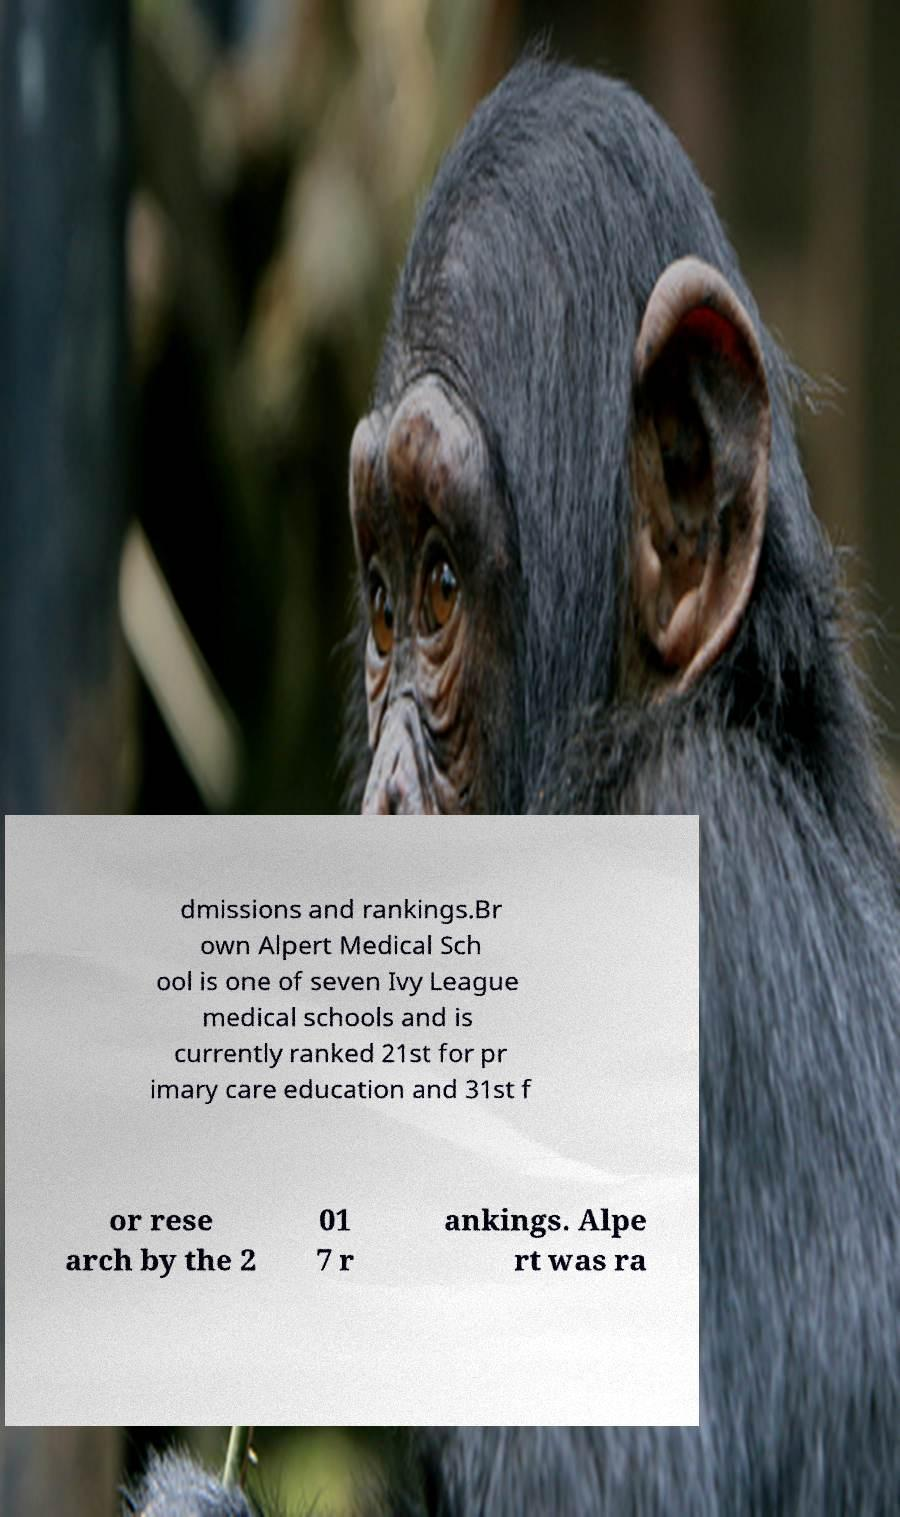Can you accurately transcribe the text from the provided image for me? dmissions and rankings.Br own Alpert Medical Sch ool is one of seven Ivy League medical schools and is currently ranked 21st for pr imary care education and 31st f or rese arch by the 2 01 7 r ankings. Alpe rt was ra 